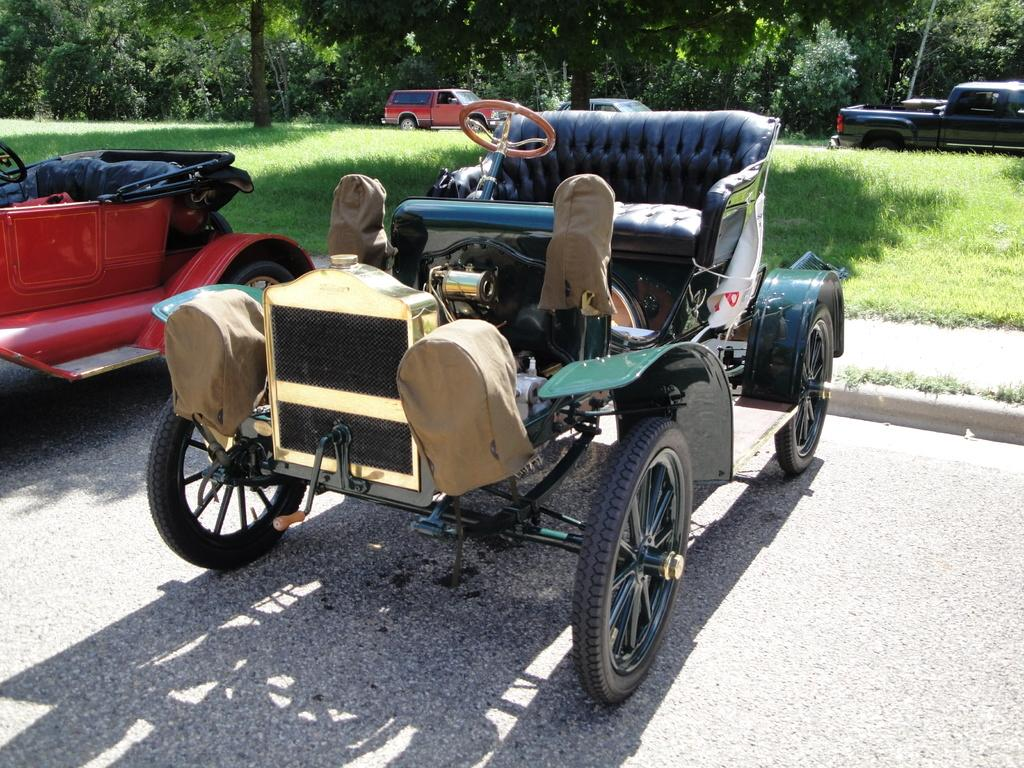What can be seen on the road in the image? There are cars parked on the road in the image. What is visible at the bottom of the image? The road is visible at the bottom of the image. What type of vegetation is present in the middle of the image? There is green grass on the ground in the middle of the image. What is visible in the background of the image? There are many trees in the background of the image. How does the fog affect the visibility of the cars in the image? There is no fog present in the image, so it does not affect the visibility of the cars. What type of crate is visible in the image? There is no crate present in the image. 